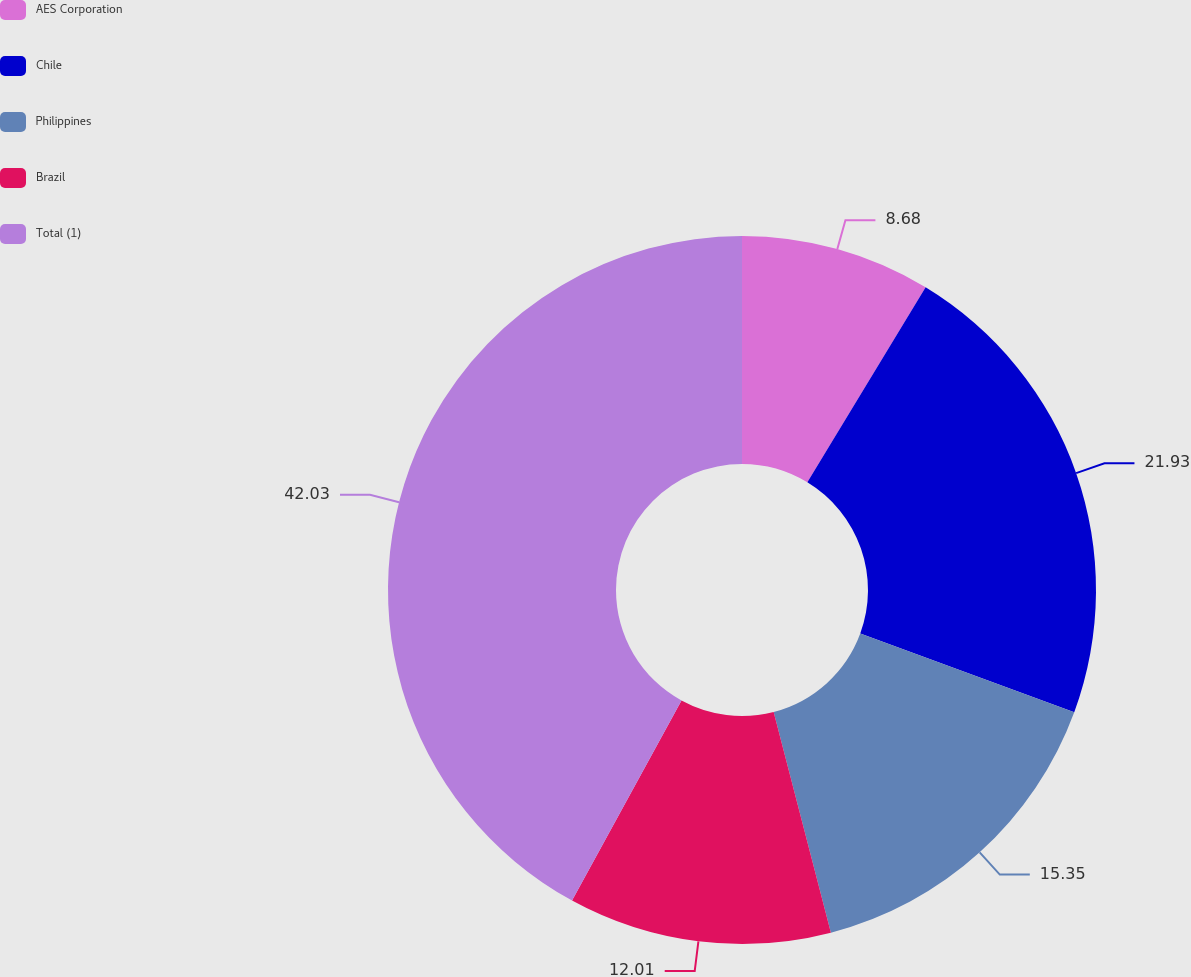<chart> <loc_0><loc_0><loc_500><loc_500><pie_chart><fcel>AES Corporation<fcel>Chile<fcel>Philippines<fcel>Brazil<fcel>Total (1)<nl><fcel>8.68%<fcel>21.93%<fcel>15.35%<fcel>12.01%<fcel>42.03%<nl></chart> 